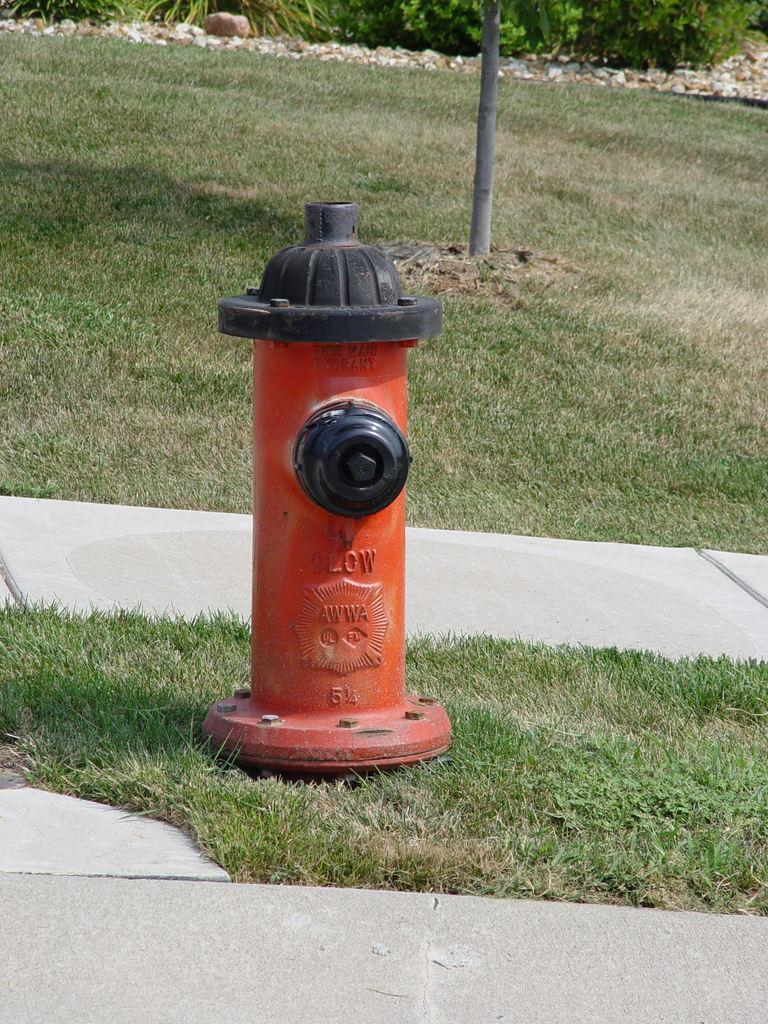What object is on the ground in the image? There is a hydrant on the ground in the image. What other object can be seen in the image? There is a pole in the image. What type of cream is being applied to the ring in the image? There is no ring or cream present in the image; it only features a hydrant and a pole. 